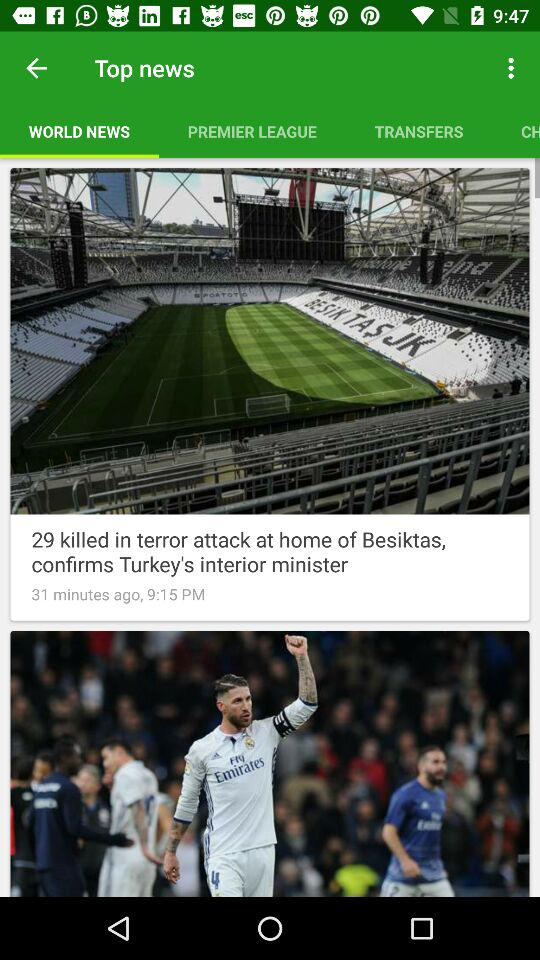How many items are in "PREMIER LEAGUE"?
When the provided information is insufficient, respond with <no answer>. <no answer> 